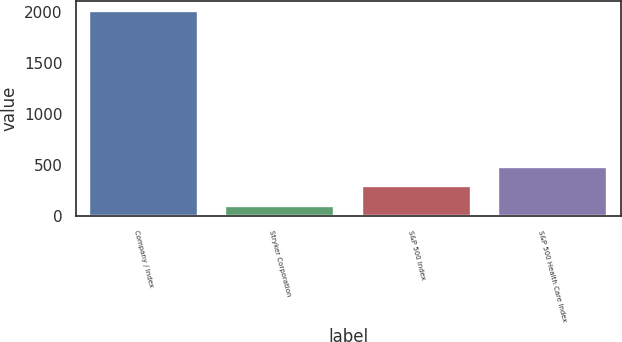Convert chart. <chart><loc_0><loc_0><loc_500><loc_500><bar_chart><fcel>Company / Index<fcel>Stryker Corporation<fcel>S&P 500 Index<fcel>S&P 500 Health Care Index<nl><fcel>2009<fcel>100<fcel>290.9<fcel>481.8<nl></chart> 